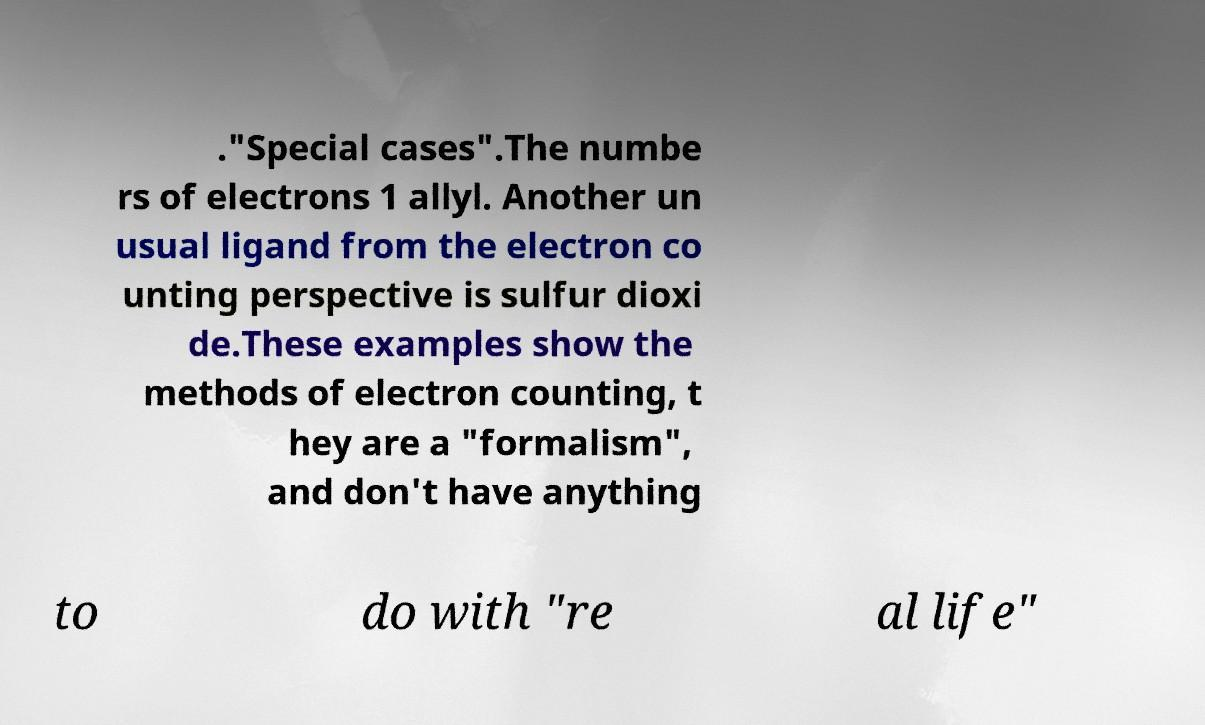What messages or text are displayed in this image? I need them in a readable, typed format. ."Special cases".The numbe rs of electrons 1 allyl. Another un usual ligand from the electron co unting perspective is sulfur dioxi de.These examples show the methods of electron counting, t hey are a "formalism", and don't have anything to do with "re al life" 